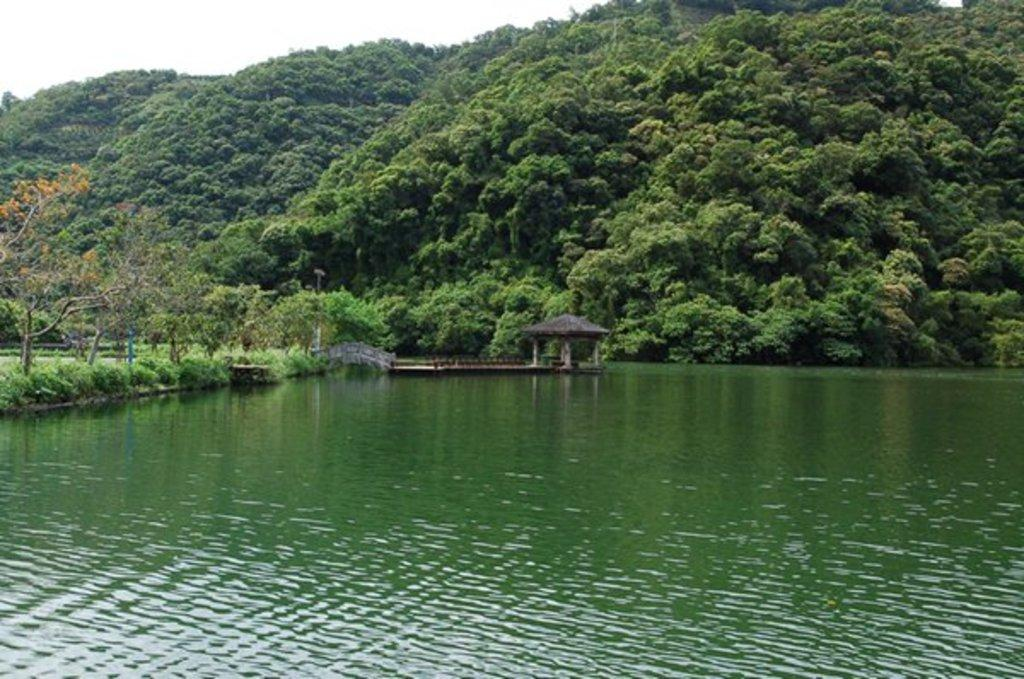What is the primary element visible in the image? There is water in the image. What type of structure can be seen in the image? There is a shed in the image. What type of vegetation is present in the image? There are trees in the image. What can be seen in the distance in the image? There are hills visible in the background of the image. What is visible above the scene in the image? The sky is visible in the background of the image. What type of vase is placed on the hill in the image? There is no vase present in the image; it only features water, a shed, trees, hills, and the sky. 